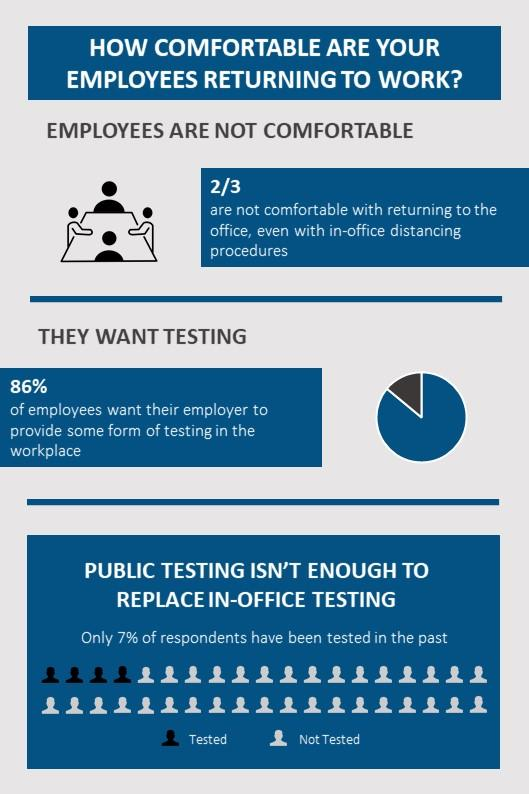Indicate a few pertinent items in this graphic. According to the information provided, approximately one-third of the employees are comfortable with the idea of returning to work. Nearly 7/8 of the employees desire some form of testing in the workplace to be provided. 